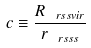Convert formula to latex. <formula><loc_0><loc_0><loc_500><loc_500>c \equiv \frac { R _ { \ r s s v i r } } { r _ { \ r s s s } }</formula> 